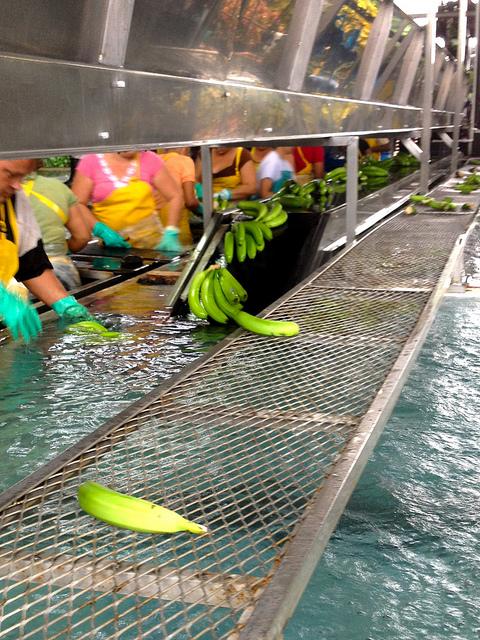Are the bananas ripe?
Short answer required. No. What are workers doing to the bananas?
Concise answer only. Washing. Is there water?
Quick response, please. Yes. 